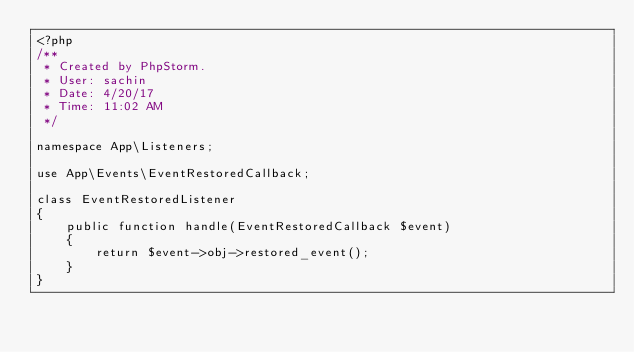Convert code to text. <code><loc_0><loc_0><loc_500><loc_500><_PHP_><?php
/**
 * Created by PhpStorm.
 * User: sachin
 * Date: 4/20/17
 * Time: 11:02 AM
 */

namespace App\Listeners;

use App\Events\EventRestoredCallback;

class EventRestoredListener
{
    public function handle(EventRestoredCallback $event)
    {
        return $event->obj->restored_event();
    }
}</code> 